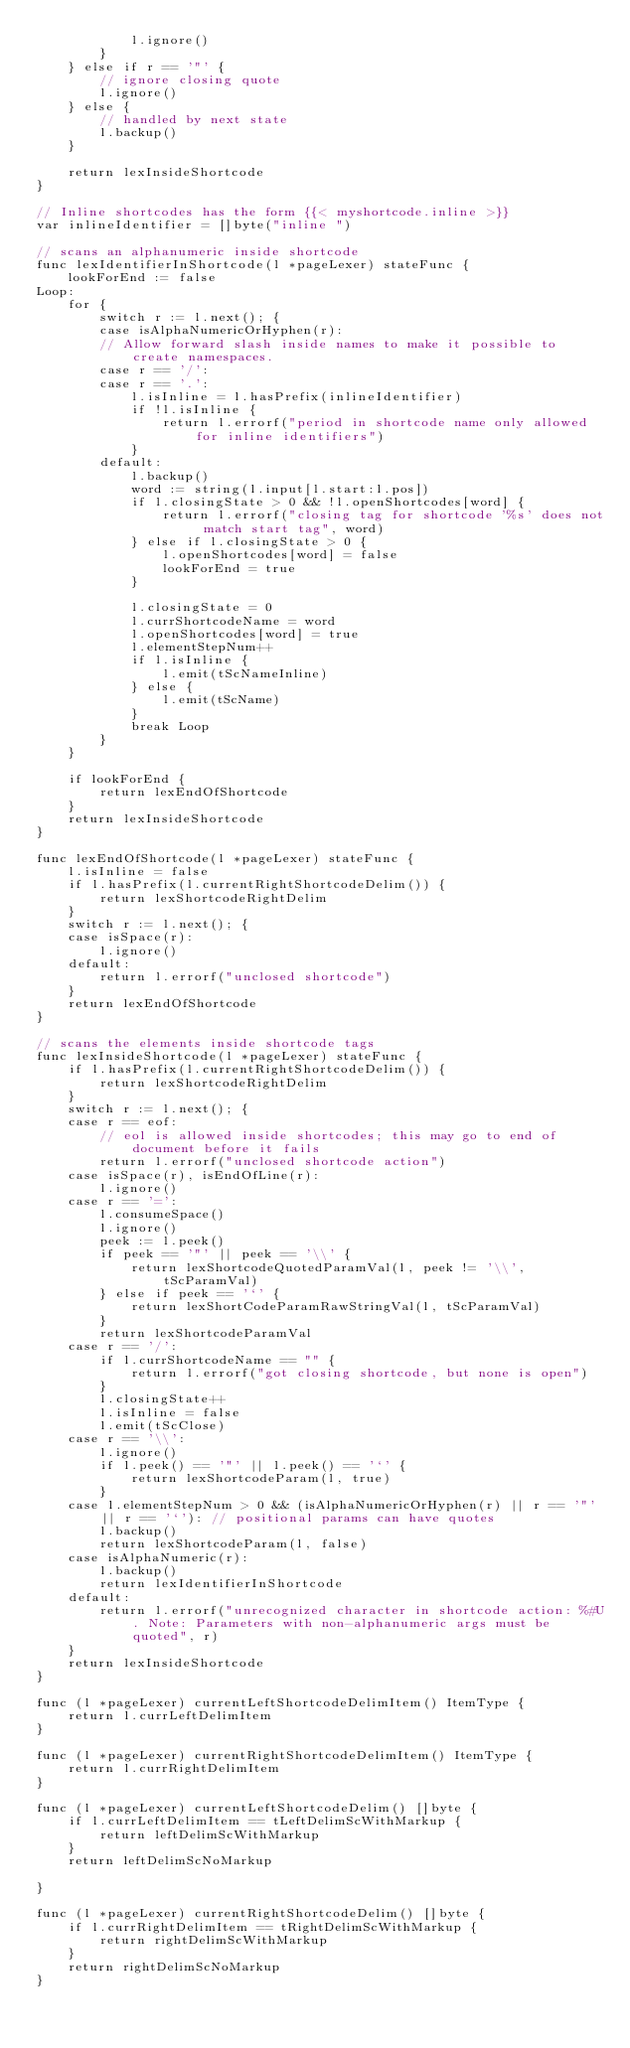Convert code to text. <code><loc_0><loc_0><loc_500><loc_500><_Go_>			l.ignore()
		}
	} else if r == '"' {
		// ignore closing quote
		l.ignore()
	} else {
		// handled by next state
		l.backup()
	}

	return lexInsideShortcode
}

// Inline shortcodes has the form {{< myshortcode.inline >}}
var inlineIdentifier = []byte("inline ")

// scans an alphanumeric inside shortcode
func lexIdentifierInShortcode(l *pageLexer) stateFunc {
	lookForEnd := false
Loop:
	for {
		switch r := l.next(); {
		case isAlphaNumericOrHyphen(r):
		// Allow forward slash inside names to make it possible to create namespaces.
		case r == '/':
		case r == '.':
			l.isInline = l.hasPrefix(inlineIdentifier)
			if !l.isInline {
				return l.errorf("period in shortcode name only allowed for inline identifiers")
			}
		default:
			l.backup()
			word := string(l.input[l.start:l.pos])
			if l.closingState > 0 && !l.openShortcodes[word] {
				return l.errorf("closing tag for shortcode '%s' does not match start tag", word)
			} else if l.closingState > 0 {
				l.openShortcodes[word] = false
				lookForEnd = true
			}

			l.closingState = 0
			l.currShortcodeName = word
			l.openShortcodes[word] = true
			l.elementStepNum++
			if l.isInline {
				l.emit(tScNameInline)
			} else {
				l.emit(tScName)
			}
			break Loop
		}
	}

	if lookForEnd {
		return lexEndOfShortcode
	}
	return lexInsideShortcode
}

func lexEndOfShortcode(l *pageLexer) stateFunc {
	l.isInline = false
	if l.hasPrefix(l.currentRightShortcodeDelim()) {
		return lexShortcodeRightDelim
	}
	switch r := l.next(); {
	case isSpace(r):
		l.ignore()
	default:
		return l.errorf("unclosed shortcode")
	}
	return lexEndOfShortcode
}

// scans the elements inside shortcode tags
func lexInsideShortcode(l *pageLexer) stateFunc {
	if l.hasPrefix(l.currentRightShortcodeDelim()) {
		return lexShortcodeRightDelim
	}
	switch r := l.next(); {
	case r == eof:
		// eol is allowed inside shortcodes; this may go to end of document before it fails
		return l.errorf("unclosed shortcode action")
	case isSpace(r), isEndOfLine(r):
		l.ignore()
	case r == '=':
		l.consumeSpace()
		l.ignore()
		peek := l.peek()
		if peek == '"' || peek == '\\' {
			return lexShortcodeQuotedParamVal(l, peek != '\\', tScParamVal)
		} else if peek == '`' {
			return lexShortCodeParamRawStringVal(l, tScParamVal)
		}
		return lexShortcodeParamVal
	case r == '/':
		if l.currShortcodeName == "" {
			return l.errorf("got closing shortcode, but none is open")
		}
		l.closingState++
		l.isInline = false
		l.emit(tScClose)
	case r == '\\':
		l.ignore()
		if l.peek() == '"' || l.peek() == '`' {
			return lexShortcodeParam(l, true)
		}
	case l.elementStepNum > 0 && (isAlphaNumericOrHyphen(r) || r == '"' || r == '`'): // positional params can have quotes
		l.backup()
		return lexShortcodeParam(l, false)
	case isAlphaNumeric(r):
		l.backup()
		return lexIdentifierInShortcode
	default:
		return l.errorf("unrecognized character in shortcode action: %#U. Note: Parameters with non-alphanumeric args must be quoted", r)
	}
	return lexInsideShortcode
}

func (l *pageLexer) currentLeftShortcodeDelimItem() ItemType {
	return l.currLeftDelimItem
}

func (l *pageLexer) currentRightShortcodeDelimItem() ItemType {
	return l.currRightDelimItem
}

func (l *pageLexer) currentLeftShortcodeDelim() []byte {
	if l.currLeftDelimItem == tLeftDelimScWithMarkup {
		return leftDelimScWithMarkup
	}
	return leftDelimScNoMarkup

}

func (l *pageLexer) currentRightShortcodeDelim() []byte {
	if l.currRightDelimItem == tRightDelimScWithMarkup {
		return rightDelimScWithMarkup
	}
	return rightDelimScNoMarkup
}
</code> 